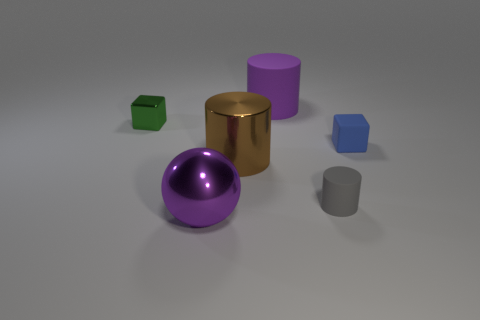What is the size of the matte cylinder that is the same color as the shiny sphere?
Ensure brevity in your answer.  Large. What shape is the big object that is left of the large brown cylinder?
Ensure brevity in your answer.  Sphere. Are there more green metal cubes than small yellow metal cylinders?
Ensure brevity in your answer.  Yes. Do the large cylinder behind the green object and the large sphere have the same color?
Your answer should be compact. Yes. How many things are either small blocks on the left side of the purple matte cylinder or rubber cylinders that are in front of the tiny metal object?
Your answer should be very brief. 2. How many objects are on the right side of the small green shiny block and behind the small gray cylinder?
Give a very brief answer. 3. Is the material of the green cube the same as the large ball?
Keep it short and to the point. Yes. There is a small object that is on the left side of the large purple thing in front of the purple object to the right of the purple shiny thing; what shape is it?
Your answer should be compact. Cube. What material is the cylinder that is both on the left side of the tiny rubber cylinder and in front of the green cube?
Keep it short and to the point. Metal. There is a big cylinder that is left of the matte cylinder that is to the left of the matte cylinder in front of the big purple matte cylinder; what is its color?
Offer a very short reply. Brown. 